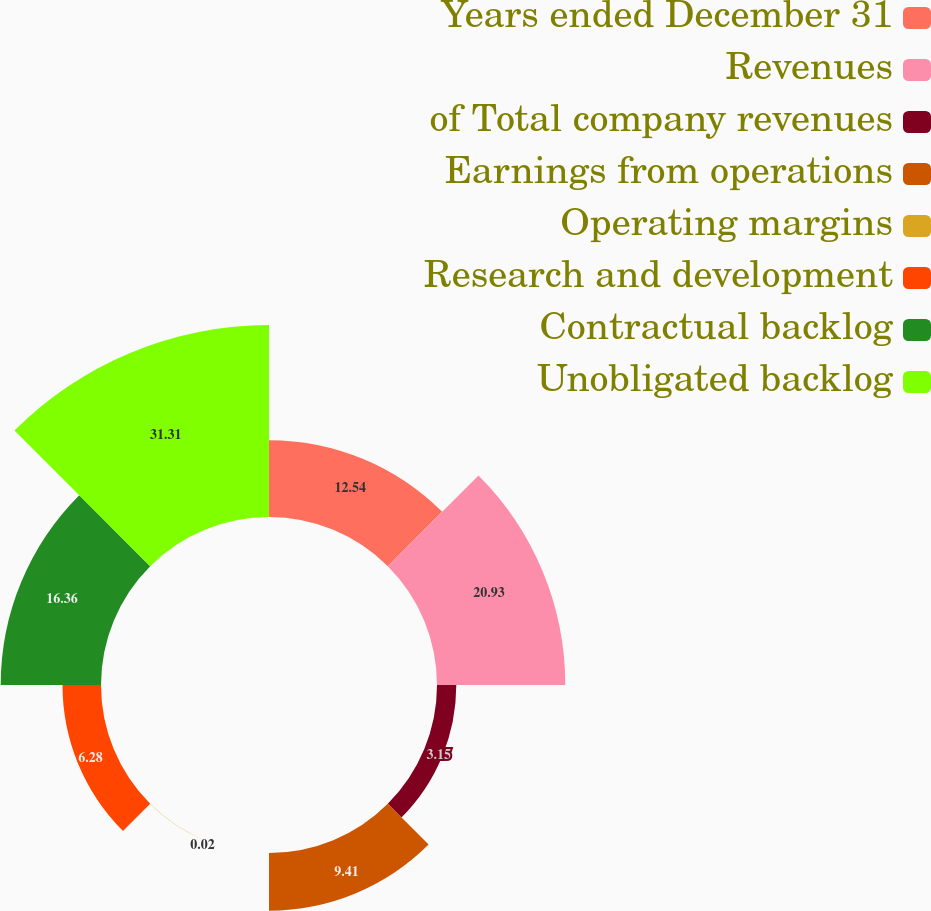Convert chart. <chart><loc_0><loc_0><loc_500><loc_500><pie_chart><fcel>Years ended December 31<fcel>Revenues<fcel>of Total company revenues<fcel>Earnings from operations<fcel>Operating margins<fcel>Research and development<fcel>Contractual backlog<fcel>Unobligated backlog<nl><fcel>12.54%<fcel>20.93%<fcel>3.15%<fcel>9.41%<fcel>0.02%<fcel>6.28%<fcel>16.36%<fcel>31.32%<nl></chart> 